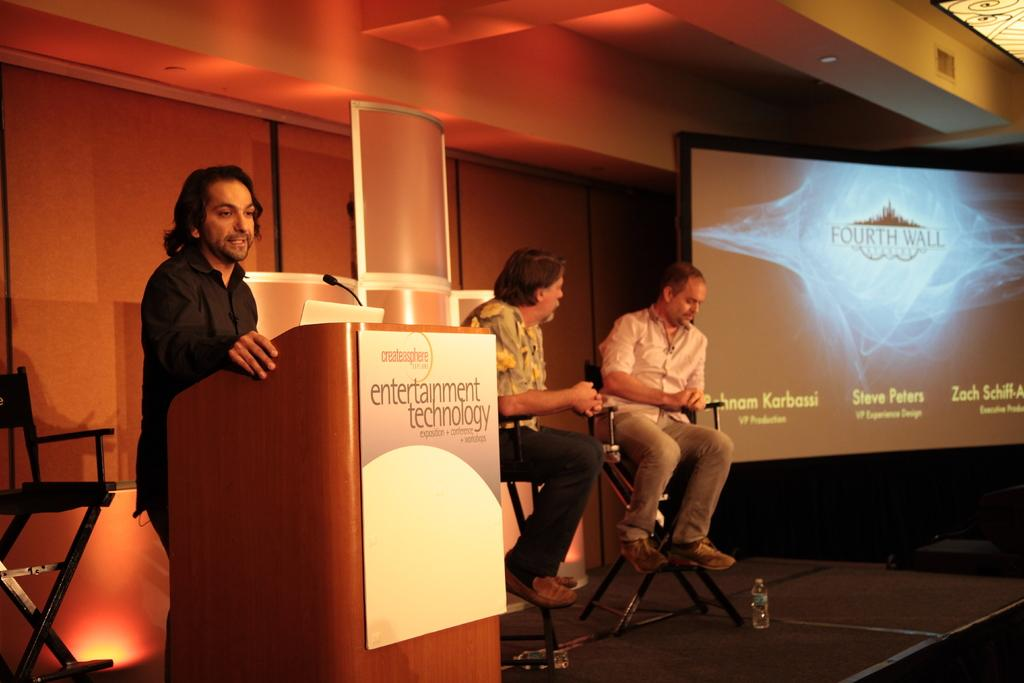Provide a one-sentence caption for the provided image. Three men on a stage giving a presentation on entertainment technology. 